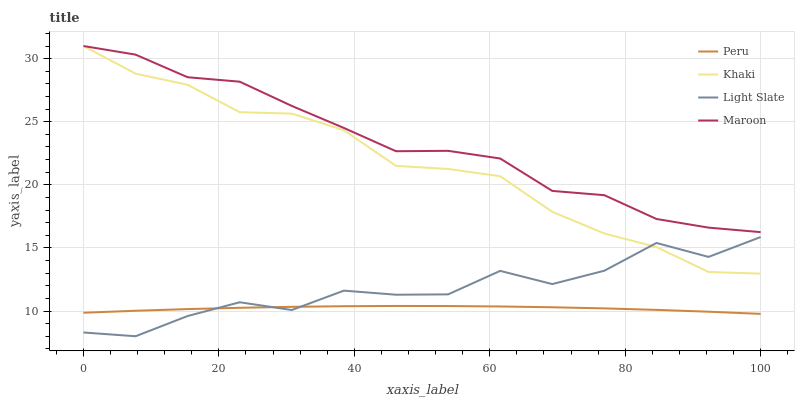Does Peru have the minimum area under the curve?
Answer yes or no. Yes. Does Maroon have the maximum area under the curve?
Answer yes or no. Yes. Does Khaki have the minimum area under the curve?
Answer yes or no. No. Does Khaki have the maximum area under the curve?
Answer yes or no. No. Is Peru the smoothest?
Answer yes or no. Yes. Is Light Slate the roughest?
Answer yes or no. Yes. Is Khaki the smoothest?
Answer yes or no. No. Is Khaki the roughest?
Answer yes or no. No. Does Light Slate have the lowest value?
Answer yes or no. Yes. Does Khaki have the lowest value?
Answer yes or no. No. Does Maroon have the highest value?
Answer yes or no. Yes. Does Peru have the highest value?
Answer yes or no. No. Is Light Slate less than Maroon?
Answer yes or no. Yes. Is Maroon greater than Peru?
Answer yes or no. Yes. Does Khaki intersect Light Slate?
Answer yes or no. Yes. Is Khaki less than Light Slate?
Answer yes or no. No. Is Khaki greater than Light Slate?
Answer yes or no. No. Does Light Slate intersect Maroon?
Answer yes or no. No. 